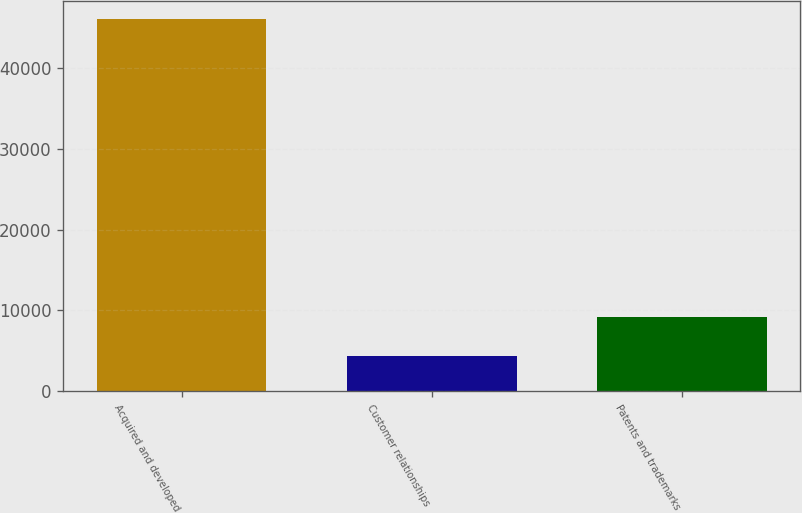Convert chart to OTSL. <chart><loc_0><loc_0><loc_500><loc_500><bar_chart><fcel>Acquired and developed<fcel>Customer relationships<fcel>Patents and trademarks<nl><fcel>46031<fcel>4376<fcel>9219<nl></chart> 